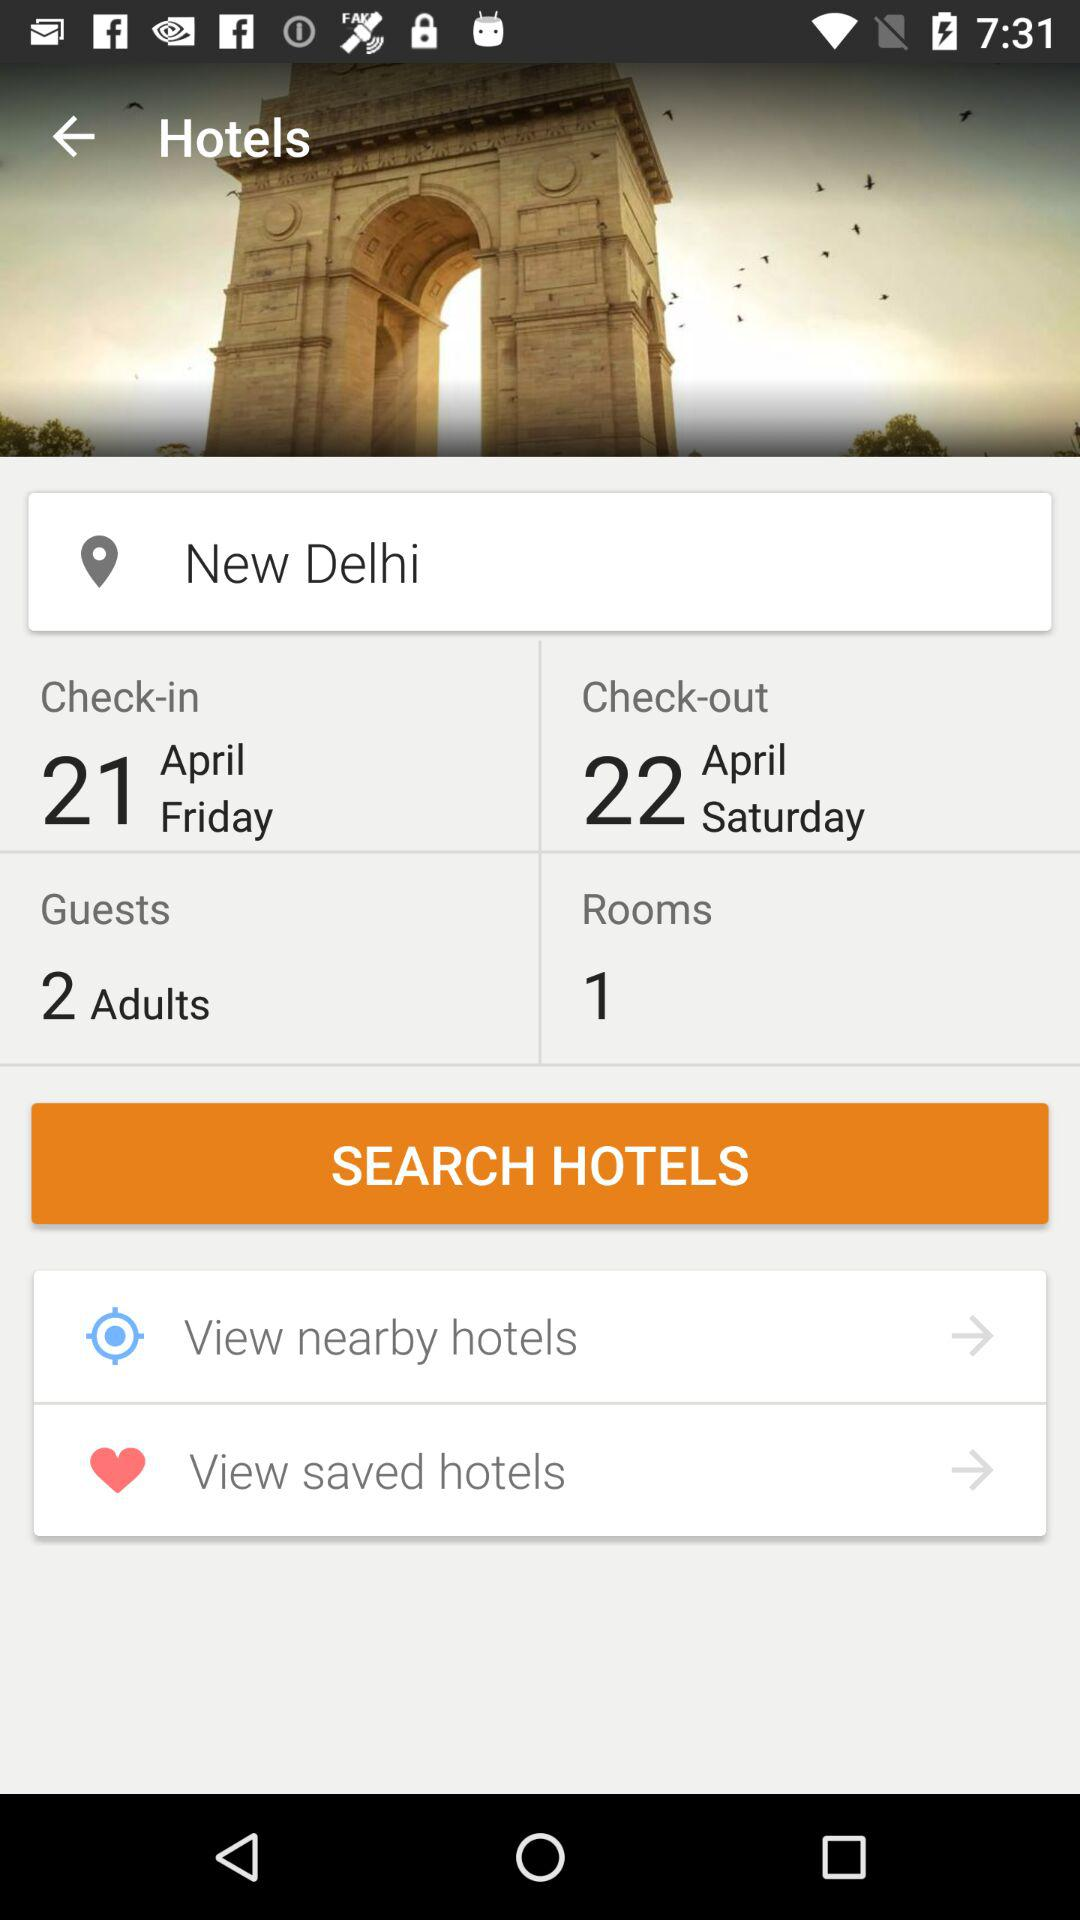How many days are between the check-in and check-out dates?
Answer the question using a single word or phrase. 1 